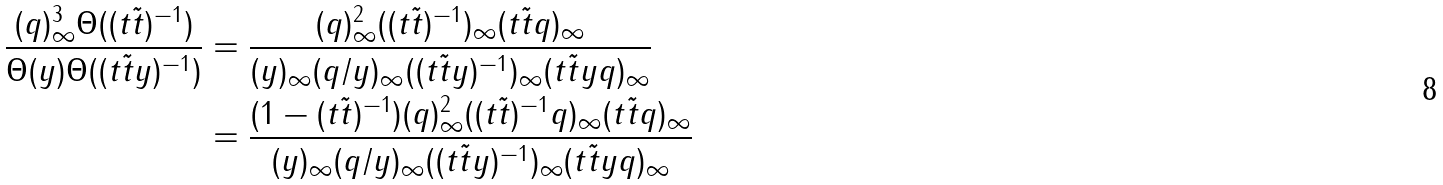<formula> <loc_0><loc_0><loc_500><loc_500>\frac { ( q ) _ { \infty } ^ { 3 } \Theta ( ( t \tilde { t } ) ^ { - 1 } ) } { \Theta ( y ) \Theta ( ( t \tilde { t } y ) ^ { - 1 } ) } & = \frac { ( q ) _ { \infty } ^ { 2 } ( ( t \tilde { t } ) ^ { - 1 } ) _ { \infty } ( t \tilde { t } q ) _ { \infty } } { ( y ) _ { \infty } ( q / y ) _ { \infty } ( ( t \tilde { t } y ) ^ { - 1 } ) _ { \infty } ( t \tilde { t } y q ) _ { \infty } } \\ & = \frac { ( 1 - ( t \tilde { t } ) ^ { - 1 } ) ( q ) _ { \infty } ^ { 2 } ( ( t \tilde { t } ) ^ { - 1 } q ) _ { \infty } ( t \tilde { t } q ) _ { \infty } } { ( y ) _ { \infty } ( q / y ) _ { \infty } ( ( t \tilde { t } y ) ^ { - 1 } ) _ { \infty } ( t \tilde { t } y q ) _ { \infty } }</formula> 